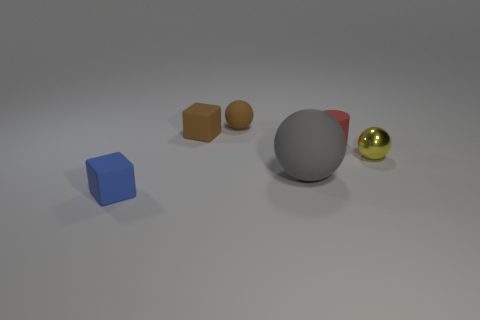Add 2 tiny cylinders. How many objects exist? 8 Subtract all blocks. How many objects are left? 4 Subtract all cyan matte spheres. Subtract all red things. How many objects are left? 5 Add 6 metallic balls. How many metallic balls are left? 7 Add 1 tiny blue things. How many tiny blue things exist? 2 Subtract 1 yellow spheres. How many objects are left? 5 